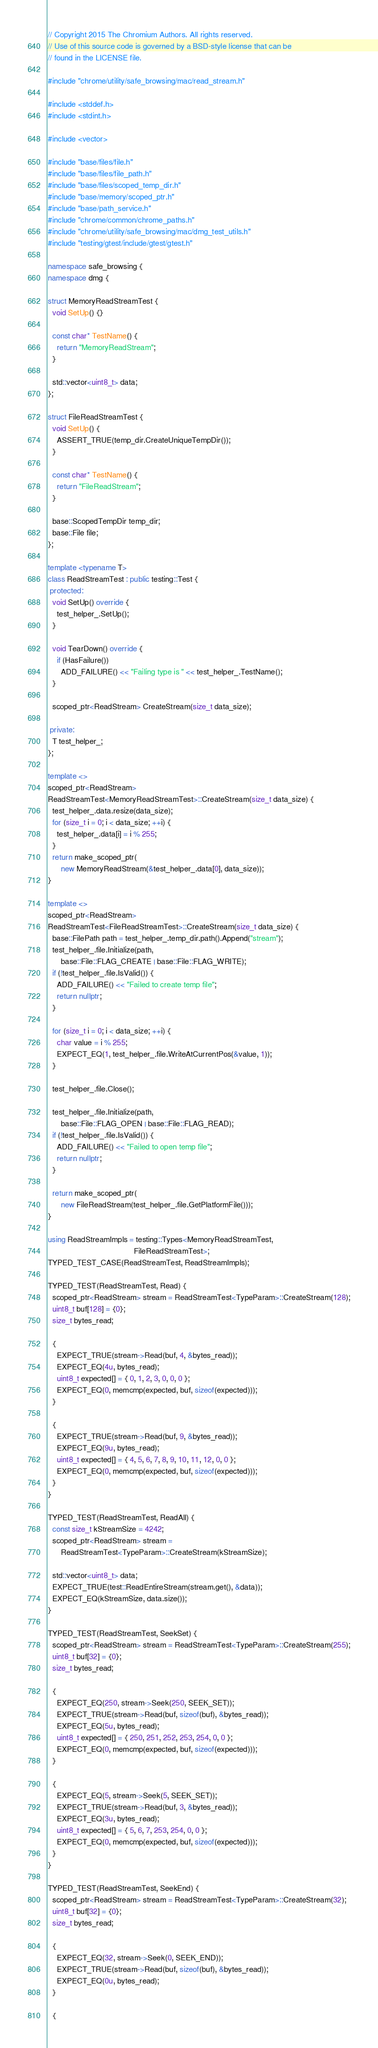<code> <loc_0><loc_0><loc_500><loc_500><_C++_>// Copyright 2015 The Chromium Authors. All rights reserved.
// Use of this source code is governed by a BSD-style license that can be
// found in the LICENSE file.

#include "chrome/utility/safe_browsing/mac/read_stream.h"

#include <stddef.h>
#include <stdint.h>

#include <vector>

#include "base/files/file.h"
#include "base/files/file_path.h"
#include "base/files/scoped_temp_dir.h"
#include "base/memory/scoped_ptr.h"
#include "base/path_service.h"
#include "chrome/common/chrome_paths.h"
#include "chrome/utility/safe_browsing/mac/dmg_test_utils.h"
#include "testing/gtest/include/gtest/gtest.h"

namespace safe_browsing {
namespace dmg {

struct MemoryReadStreamTest {
  void SetUp() {}

  const char* TestName() {
    return "MemoryReadStream";
  }

  std::vector<uint8_t> data;
};

struct FileReadStreamTest {
  void SetUp() {
    ASSERT_TRUE(temp_dir.CreateUniqueTempDir());
  }

  const char* TestName() {
    return "FileReadStream";
  }

  base::ScopedTempDir temp_dir;
  base::File file;
};

template <typename T>
class ReadStreamTest : public testing::Test {
 protected:
  void SetUp() override {
    test_helper_.SetUp();
  }

  void TearDown() override {
    if (HasFailure())
      ADD_FAILURE() << "Failing type is " << test_helper_.TestName();
  }

  scoped_ptr<ReadStream> CreateStream(size_t data_size);

 private:
  T test_helper_;
};

template <>
scoped_ptr<ReadStream>
ReadStreamTest<MemoryReadStreamTest>::CreateStream(size_t data_size) {
  test_helper_.data.resize(data_size);
  for (size_t i = 0; i < data_size; ++i) {
    test_helper_.data[i] = i % 255;
  }
  return make_scoped_ptr(
      new MemoryReadStream(&test_helper_.data[0], data_size));
}

template <>
scoped_ptr<ReadStream>
ReadStreamTest<FileReadStreamTest>::CreateStream(size_t data_size) {
  base::FilePath path = test_helper_.temp_dir.path().Append("stream");
  test_helper_.file.Initialize(path,
      base::File::FLAG_CREATE | base::File::FLAG_WRITE);
  if (!test_helper_.file.IsValid()) {
    ADD_FAILURE() << "Failed to create temp file";
    return nullptr;
  }

  for (size_t i = 0; i < data_size; ++i) {
    char value = i % 255;
    EXPECT_EQ(1, test_helper_.file.WriteAtCurrentPos(&value, 1));
  }

  test_helper_.file.Close();

  test_helper_.file.Initialize(path,
      base::File::FLAG_OPEN | base::File::FLAG_READ);
  if (!test_helper_.file.IsValid()) {
    ADD_FAILURE() << "Failed to open temp file";
    return nullptr;
  }

  return make_scoped_ptr(
      new FileReadStream(test_helper_.file.GetPlatformFile()));
}

using ReadStreamImpls = testing::Types<MemoryReadStreamTest,
                                       FileReadStreamTest>;
TYPED_TEST_CASE(ReadStreamTest, ReadStreamImpls);

TYPED_TEST(ReadStreamTest, Read) {
  scoped_ptr<ReadStream> stream = ReadStreamTest<TypeParam>::CreateStream(128);
  uint8_t buf[128] = {0};
  size_t bytes_read;

  {
    EXPECT_TRUE(stream->Read(buf, 4, &bytes_read));
    EXPECT_EQ(4u, bytes_read);
    uint8_t expected[] = { 0, 1, 2, 3, 0, 0, 0 };
    EXPECT_EQ(0, memcmp(expected, buf, sizeof(expected)));
  }

  {
    EXPECT_TRUE(stream->Read(buf, 9, &bytes_read));
    EXPECT_EQ(9u, bytes_read);
    uint8_t expected[] = { 4, 5, 6, 7, 8, 9, 10, 11, 12, 0, 0 };
    EXPECT_EQ(0, memcmp(expected, buf, sizeof(expected)));
  }
}

TYPED_TEST(ReadStreamTest, ReadAll) {
  const size_t kStreamSize = 4242;
  scoped_ptr<ReadStream> stream =
      ReadStreamTest<TypeParam>::CreateStream(kStreamSize);

  std::vector<uint8_t> data;
  EXPECT_TRUE(test::ReadEntireStream(stream.get(), &data));
  EXPECT_EQ(kStreamSize, data.size());
}

TYPED_TEST(ReadStreamTest, SeekSet) {
  scoped_ptr<ReadStream> stream = ReadStreamTest<TypeParam>::CreateStream(255);
  uint8_t buf[32] = {0};
  size_t bytes_read;

  {
    EXPECT_EQ(250, stream->Seek(250, SEEK_SET));
    EXPECT_TRUE(stream->Read(buf, sizeof(buf), &bytes_read));
    EXPECT_EQ(5u, bytes_read);
    uint8_t expected[] = { 250, 251, 252, 253, 254, 0, 0 };
    EXPECT_EQ(0, memcmp(expected, buf, sizeof(expected)));
  }

  {
    EXPECT_EQ(5, stream->Seek(5, SEEK_SET));
    EXPECT_TRUE(stream->Read(buf, 3, &bytes_read));
    EXPECT_EQ(3u, bytes_read);
    uint8_t expected[] = { 5, 6, 7, 253, 254, 0, 0 };
    EXPECT_EQ(0, memcmp(expected, buf, sizeof(expected)));
  }
}

TYPED_TEST(ReadStreamTest, SeekEnd) {
  scoped_ptr<ReadStream> stream = ReadStreamTest<TypeParam>::CreateStream(32);
  uint8_t buf[32] = {0};
  size_t bytes_read;

  {
    EXPECT_EQ(32, stream->Seek(0, SEEK_END));
    EXPECT_TRUE(stream->Read(buf, sizeof(buf), &bytes_read));
    EXPECT_EQ(0u, bytes_read);
  }

  {</code> 